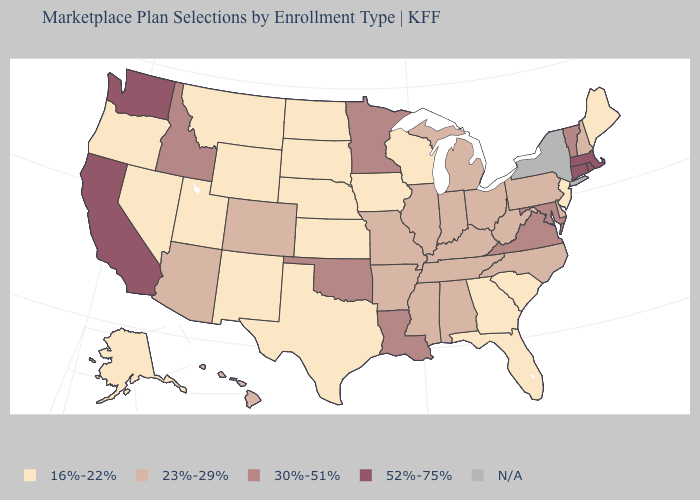Is the legend a continuous bar?
Quick response, please. No. Name the states that have a value in the range 30%-51%?
Keep it brief. Idaho, Louisiana, Maryland, Minnesota, Oklahoma, Vermont, Virginia. Name the states that have a value in the range 16%-22%?
Be succinct. Alaska, Florida, Georgia, Iowa, Kansas, Maine, Montana, Nebraska, Nevada, New Jersey, New Mexico, North Dakota, Oregon, South Carolina, South Dakota, Texas, Utah, Wisconsin, Wyoming. Is the legend a continuous bar?
Be succinct. No. What is the value of Illinois?
Quick response, please. 23%-29%. Name the states that have a value in the range 52%-75%?
Quick response, please. California, Connecticut, Massachusetts, Rhode Island, Washington. What is the highest value in the USA?
Concise answer only. 52%-75%. Which states have the lowest value in the USA?
Keep it brief. Alaska, Florida, Georgia, Iowa, Kansas, Maine, Montana, Nebraska, Nevada, New Jersey, New Mexico, North Dakota, Oregon, South Carolina, South Dakota, Texas, Utah, Wisconsin, Wyoming. Does Washington have the highest value in the USA?
Write a very short answer. Yes. Among the states that border New Mexico , does Texas have the lowest value?
Answer briefly. Yes. Does the map have missing data?
Write a very short answer. Yes. What is the value of Alaska?
Keep it brief. 16%-22%. What is the value of Indiana?
Be succinct. 23%-29%. 